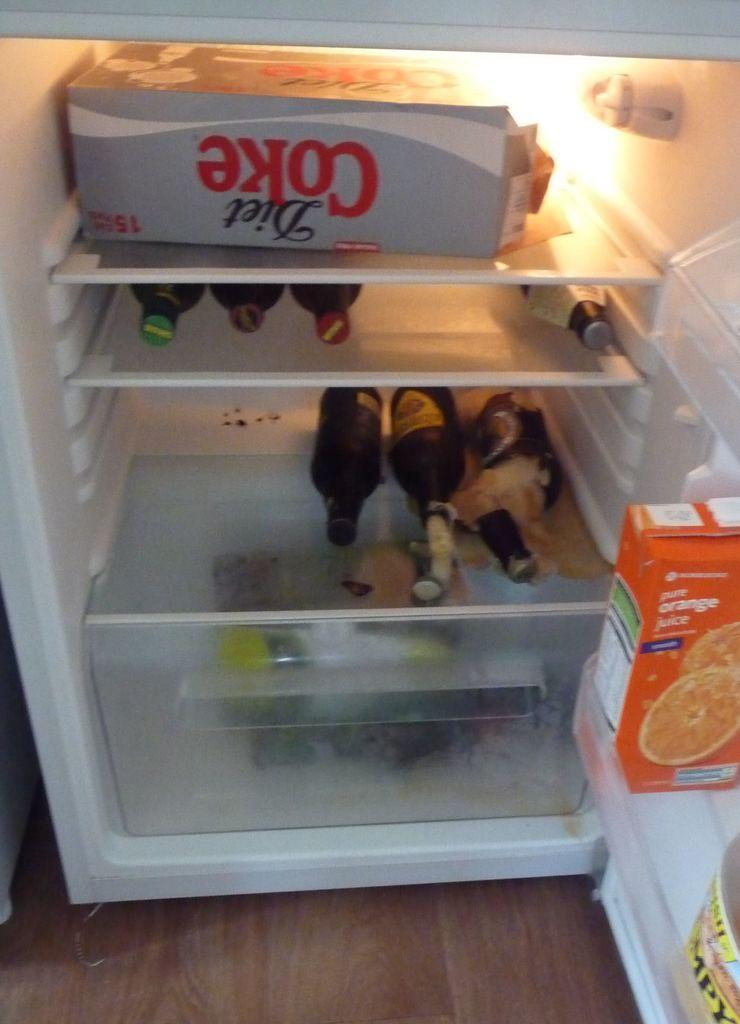What type of appliance is visible in the image? There is a refrigerator in the image. How is the refrigerator positioned in the image? The refrigerator is placed on the floor. What is the state of the refrigerator door in the image? The refrigerator door is opened. What types of items can be seen inside the refrigerator? There are boxes and bottles inside the refrigerator. What type of boats are being discussed in the meeting taking place in front of the refrigerator? There is no meeting or boats present in the image; it only features a refrigerator with an opened door. 